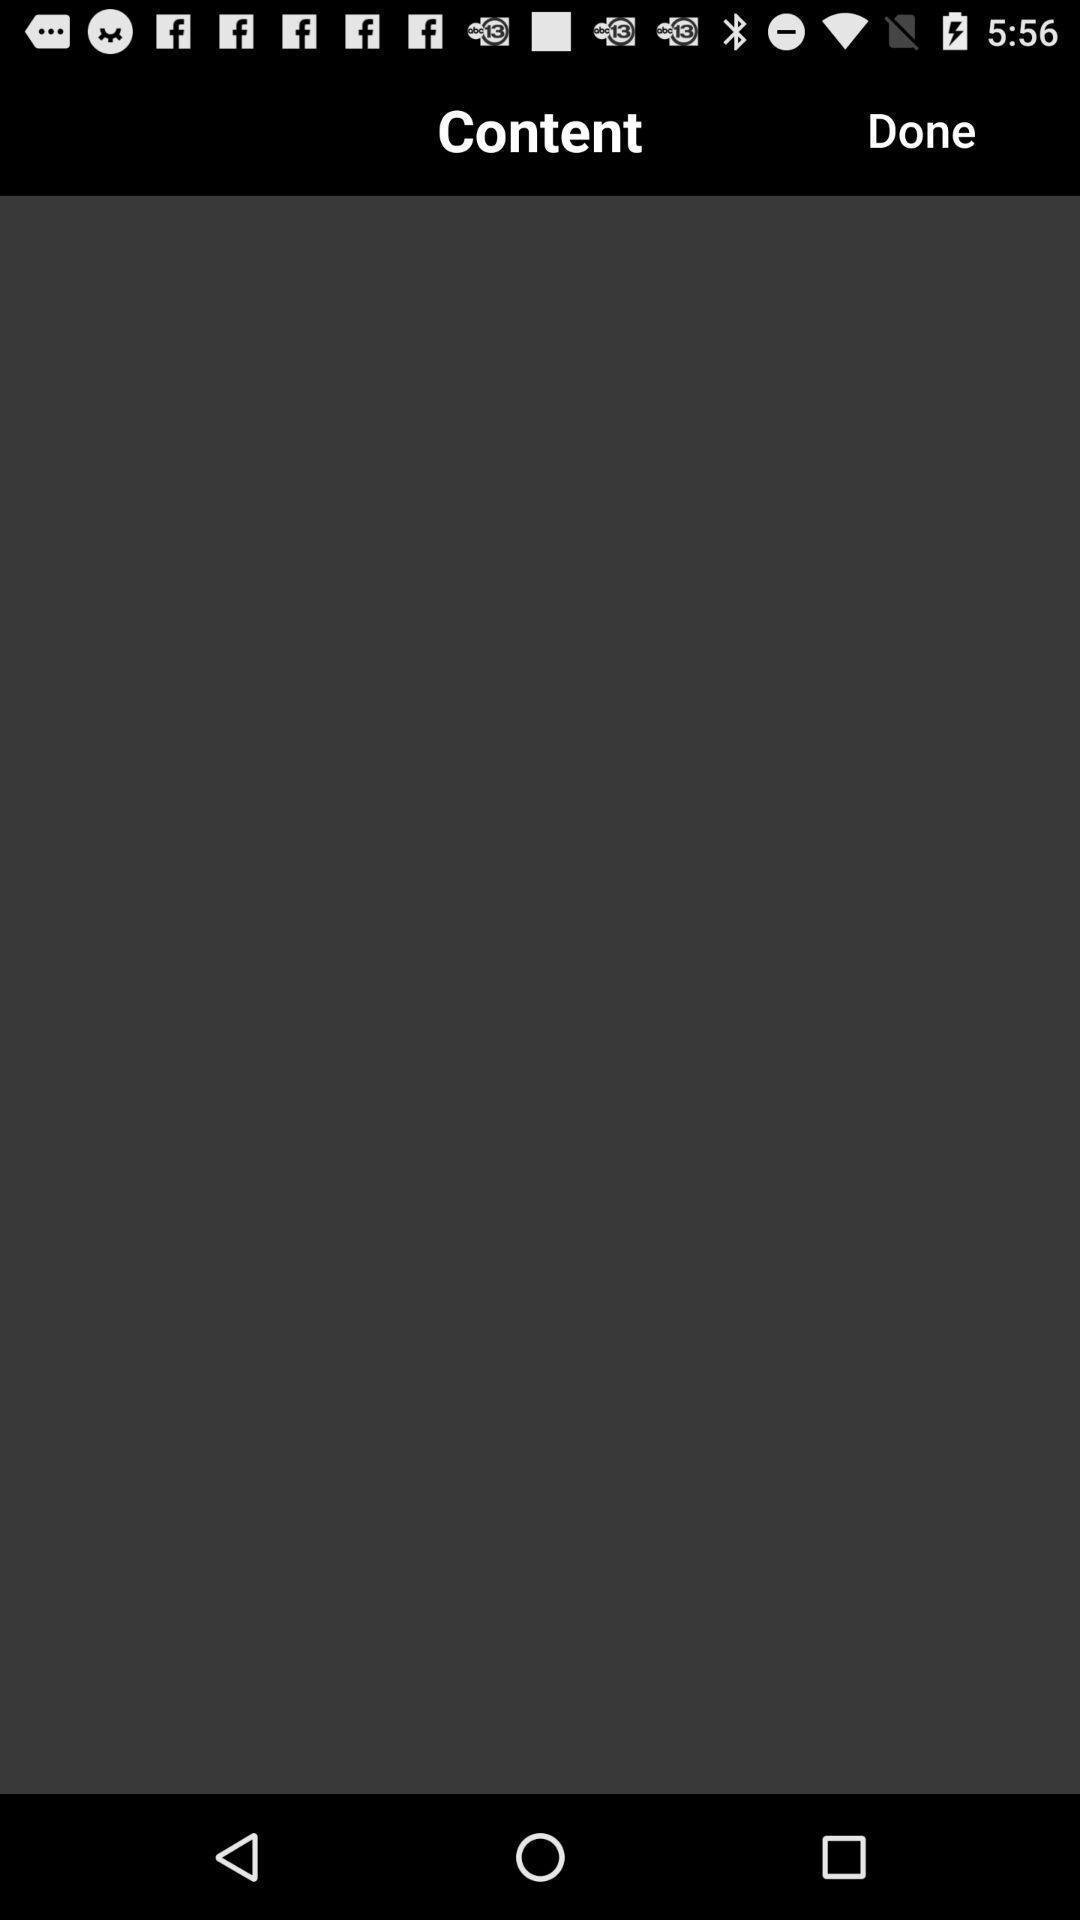Please provide a description for this image. Page displaying the blank under the content option. 